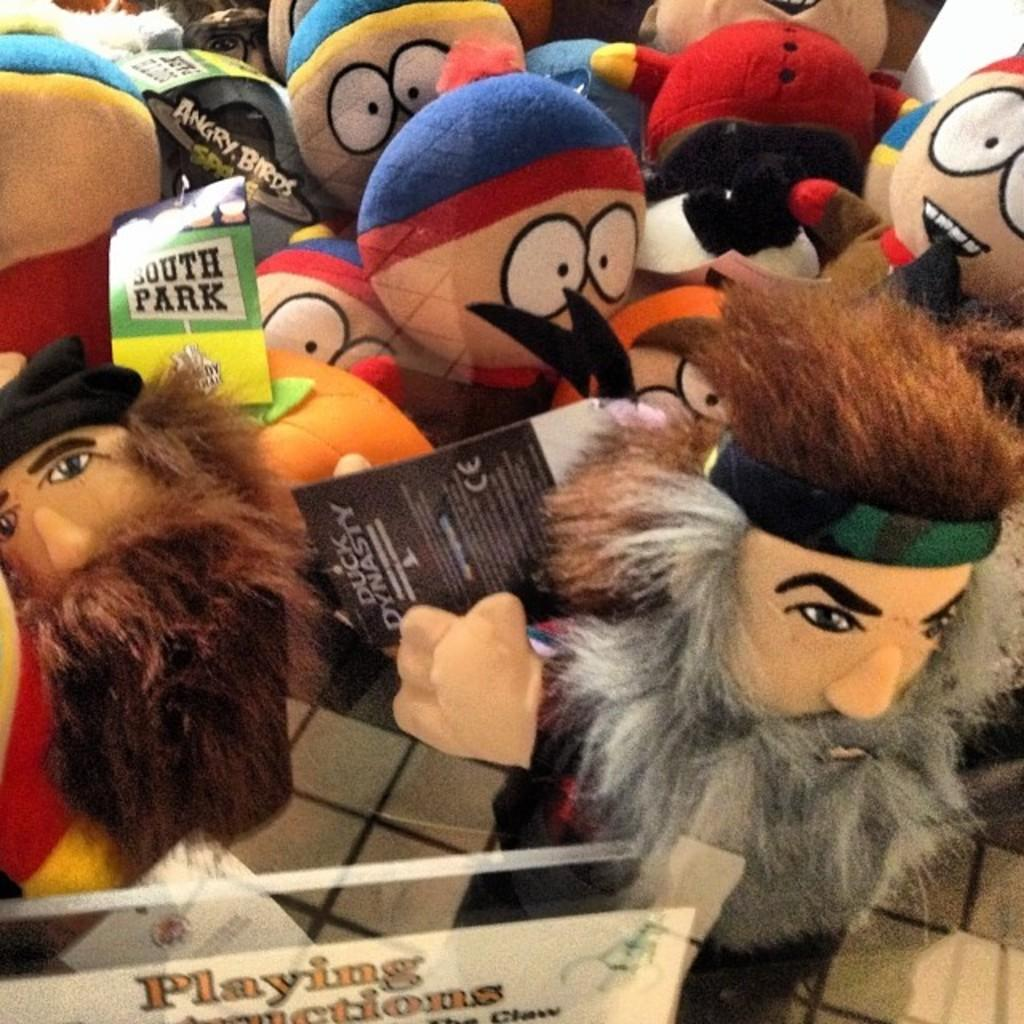What type of objects can be seen in the image? There are toys and boards in the image. What is written or depicted on the boards? There is text on the boards. What is the surface beneath the objects in the image? The bottom of the image appears to be a floor. Reasoning: Let's think step by following the guidelines to produce the conversation. We start by identifying the main objects in the image, which are toys and boards. Then, we describe the specific details about the boards, such as the presence of text. Finally, we mention the surface beneath the objects, which is the floor. Each question is designed to elicit a specific detail about the image that is known from the provided facts. Absurd Question/Answer: How does the image convey a sense of self? The image does not convey a sense of self, as it only contains toys, boards, and text. 